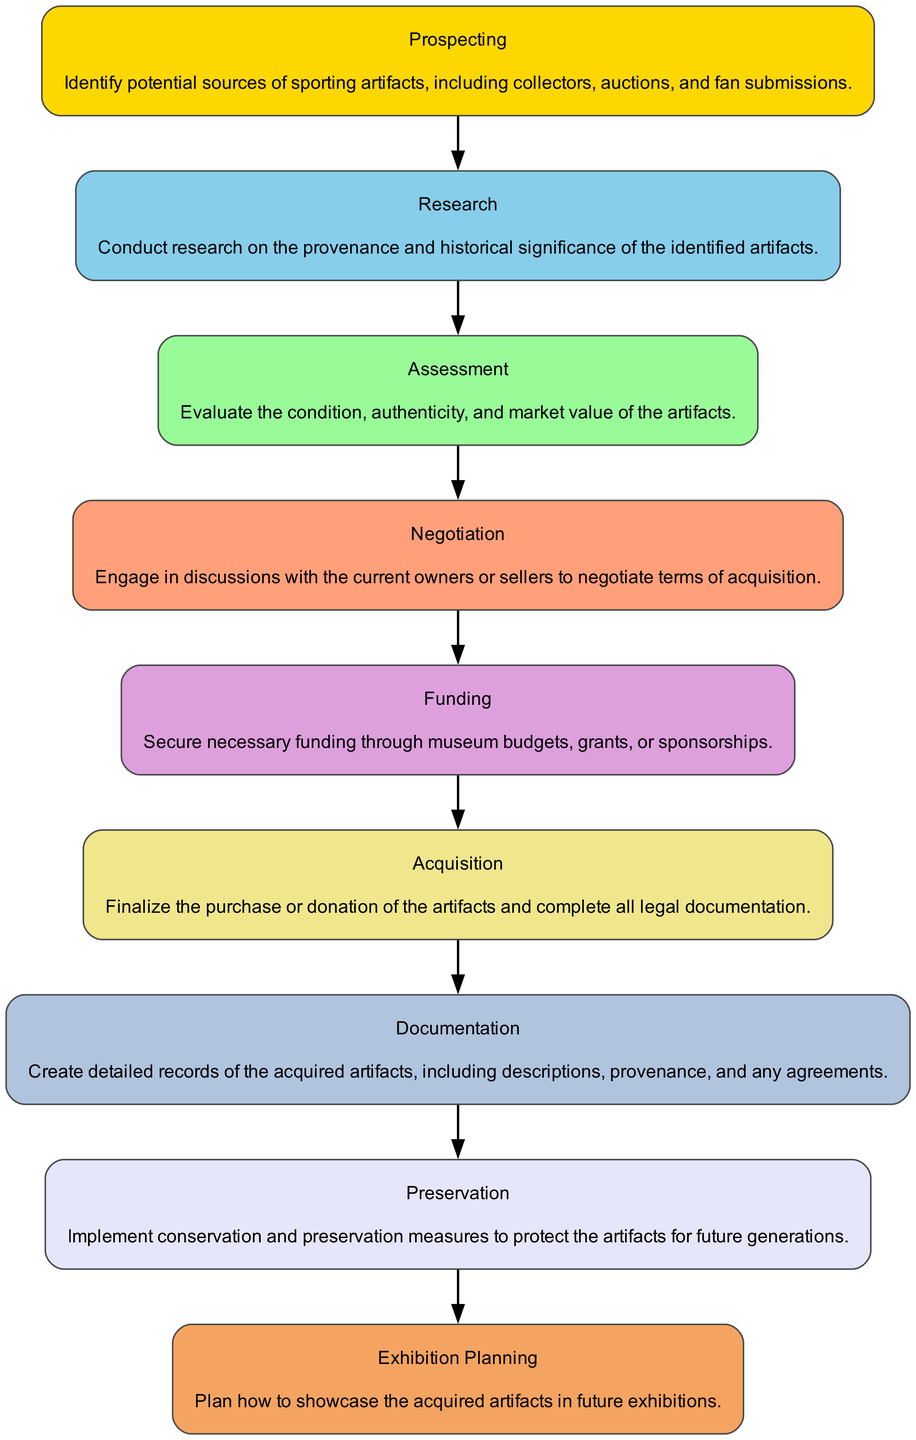What is the first step in the acquisition process? The first step according to the flow chart is "Prospecting," which is where potential sources of sporting artifacts are identified.
Answer: Prospecting How many steps are there in the acquisition process? By counting the steps listed in the flow chart, there are a total of nine steps involved in the acquisition process for sporting artifacts.
Answer: Nine What step comes after "Research"? In the flow chart, the step that directly follows "Research" is "Assessment," where the condition, authenticity, and market value of the artifacts are evaluated.
Answer: Assessment Which step involves securing funds? The step dedicated to securing necessary funding through museum budgets, grants, or sponsorships is "Funding."
Answer: Funding What is the last step in the acquisition process? The final step in the acquisition process is "Exhibition Planning," which involves planning how to showcase the acquired artifacts in future exhibitions.
Answer: Exhibition Planning How many edges (connections) are in the flow chart? Each step connects to the next in a linear fashion, leading to a total of eight edges in the flow chart since there are nine steps.
Answer: Eight What is the primary task during the "Negotiation" step? During the "Negotiation" step, the primary task is to engage in discussions with the current owners or sellers to negotiate terms of acquisition.
Answer: Discussing terms Which two steps immediately precede "Acquisition"? The two steps that precede "Acquisition" in the flow chart are "Funding" and "Negotiation," which involve securing funds and engaging in discussions with current owners.
Answer: Funding and Negotiation What process is emphasized in the step titled "Preservation"? The "Preservation" step focuses on implementing conservation and preservation measures to protect the artifacts for future generations.
Answer: Conservation and preservation 